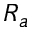Convert formula to latex. <formula><loc_0><loc_0><loc_500><loc_500>R _ { a }</formula> 